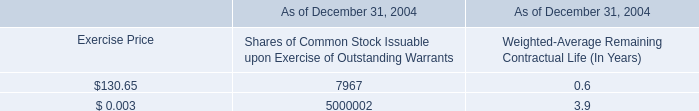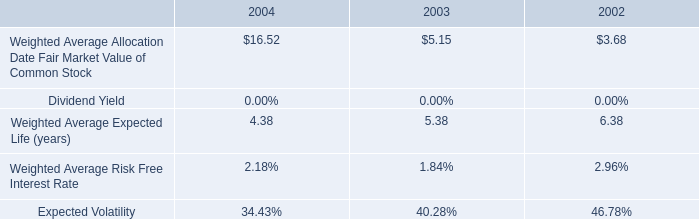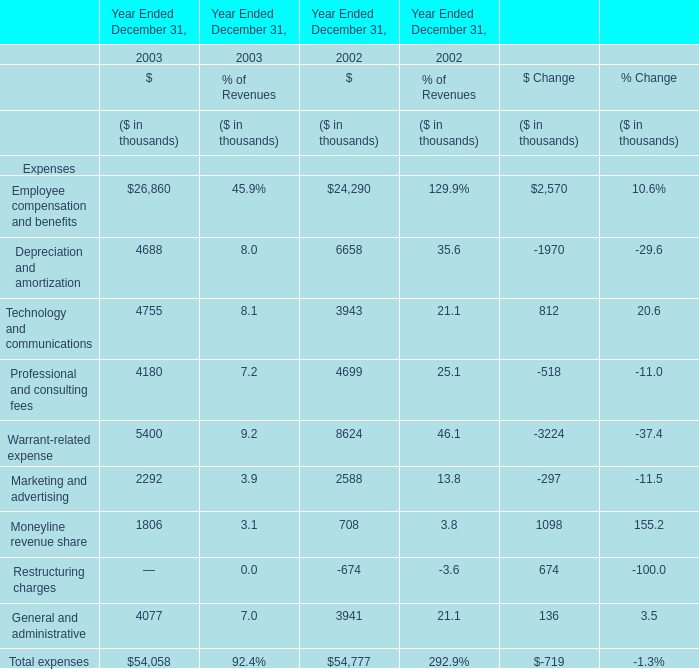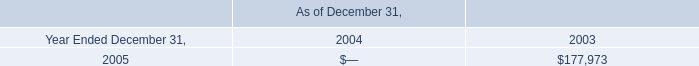as of december 31 , 2004 , how many shares of common stock were outstanding? 
Computations: (110000000 + 10000000)
Answer: 120000000.0. 